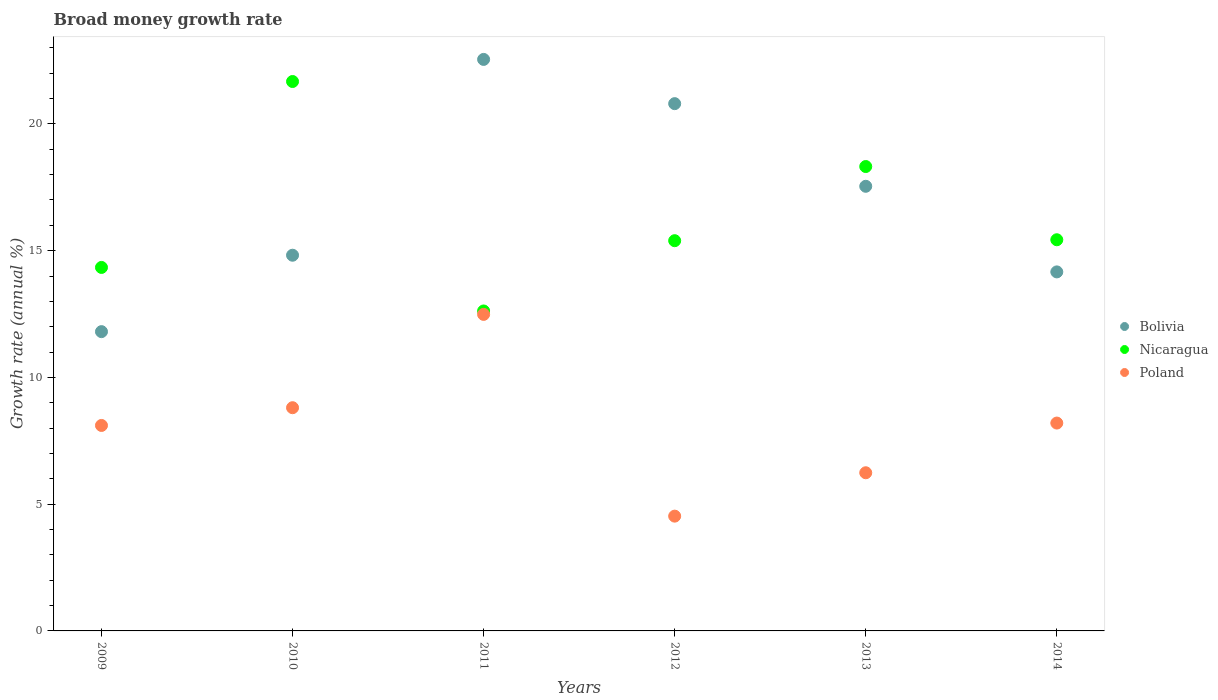How many different coloured dotlines are there?
Keep it short and to the point. 3. Is the number of dotlines equal to the number of legend labels?
Make the answer very short. Yes. What is the growth rate in Nicaragua in 2013?
Provide a succinct answer. 18.32. Across all years, what is the maximum growth rate in Nicaragua?
Your answer should be very brief. 21.67. Across all years, what is the minimum growth rate in Poland?
Your answer should be very brief. 4.53. In which year was the growth rate in Bolivia minimum?
Keep it short and to the point. 2009. What is the total growth rate in Poland in the graph?
Give a very brief answer. 48.36. What is the difference between the growth rate in Bolivia in 2009 and that in 2011?
Offer a terse response. -10.74. What is the difference between the growth rate in Nicaragua in 2011 and the growth rate in Poland in 2014?
Offer a very short reply. 4.42. What is the average growth rate in Poland per year?
Your answer should be compact. 8.06. In the year 2011, what is the difference between the growth rate in Poland and growth rate in Bolivia?
Ensure brevity in your answer.  -10.06. In how many years, is the growth rate in Poland greater than 14 %?
Ensure brevity in your answer.  0. What is the ratio of the growth rate in Nicaragua in 2010 to that in 2013?
Offer a terse response. 1.18. What is the difference between the highest and the second highest growth rate in Bolivia?
Ensure brevity in your answer.  1.75. What is the difference between the highest and the lowest growth rate in Poland?
Provide a succinct answer. 7.96. Is it the case that in every year, the sum of the growth rate in Bolivia and growth rate in Nicaragua  is greater than the growth rate in Poland?
Provide a succinct answer. Yes. Does the growth rate in Nicaragua monotonically increase over the years?
Your response must be concise. No. Is the growth rate in Nicaragua strictly greater than the growth rate in Poland over the years?
Give a very brief answer. Yes. Is the growth rate in Bolivia strictly less than the growth rate in Poland over the years?
Ensure brevity in your answer.  No. How many dotlines are there?
Your response must be concise. 3. How many years are there in the graph?
Offer a very short reply. 6. What is the difference between two consecutive major ticks on the Y-axis?
Offer a terse response. 5. Does the graph contain any zero values?
Ensure brevity in your answer.  No. What is the title of the graph?
Give a very brief answer. Broad money growth rate. What is the label or title of the Y-axis?
Keep it short and to the point. Growth rate (annual %). What is the Growth rate (annual %) in Bolivia in 2009?
Provide a short and direct response. 11.81. What is the Growth rate (annual %) in Nicaragua in 2009?
Give a very brief answer. 14.34. What is the Growth rate (annual %) in Poland in 2009?
Give a very brief answer. 8.11. What is the Growth rate (annual %) in Bolivia in 2010?
Make the answer very short. 14.82. What is the Growth rate (annual %) of Nicaragua in 2010?
Provide a succinct answer. 21.67. What is the Growth rate (annual %) of Poland in 2010?
Offer a very short reply. 8.81. What is the Growth rate (annual %) in Bolivia in 2011?
Your answer should be very brief. 22.55. What is the Growth rate (annual %) in Nicaragua in 2011?
Give a very brief answer. 12.62. What is the Growth rate (annual %) in Poland in 2011?
Your answer should be compact. 12.49. What is the Growth rate (annual %) of Bolivia in 2012?
Make the answer very short. 20.8. What is the Growth rate (annual %) in Nicaragua in 2012?
Offer a very short reply. 15.39. What is the Growth rate (annual %) in Poland in 2012?
Your answer should be very brief. 4.53. What is the Growth rate (annual %) in Bolivia in 2013?
Your answer should be compact. 17.54. What is the Growth rate (annual %) of Nicaragua in 2013?
Your answer should be compact. 18.32. What is the Growth rate (annual %) in Poland in 2013?
Your answer should be compact. 6.24. What is the Growth rate (annual %) of Bolivia in 2014?
Provide a succinct answer. 14.16. What is the Growth rate (annual %) of Nicaragua in 2014?
Offer a terse response. 15.43. What is the Growth rate (annual %) in Poland in 2014?
Offer a very short reply. 8.2. Across all years, what is the maximum Growth rate (annual %) of Bolivia?
Your answer should be very brief. 22.55. Across all years, what is the maximum Growth rate (annual %) in Nicaragua?
Your answer should be compact. 21.67. Across all years, what is the maximum Growth rate (annual %) in Poland?
Offer a terse response. 12.49. Across all years, what is the minimum Growth rate (annual %) in Bolivia?
Offer a terse response. 11.81. Across all years, what is the minimum Growth rate (annual %) of Nicaragua?
Provide a succinct answer. 12.62. Across all years, what is the minimum Growth rate (annual %) in Poland?
Keep it short and to the point. 4.53. What is the total Growth rate (annual %) in Bolivia in the graph?
Offer a very short reply. 101.67. What is the total Growth rate (annual %) of Nicaragua in the graph?
Provide a short and direct response. 97.78. What is the total Growth rate (annual %) of Poland in the graph?
Make the answer very short. 48.36. What is the difference between the Growth rate (annual %) of Bolivia in 2009 and that in 2010?
Offer a terse response. -3.01. What is the difference between the Growth rate (annual %) in Nicaragua in 2009 and that in 2010?
Offer a terse response. -7.33. What is the difference between the Growth rate (annual %) of Poland in 2009 and that in 2010?
Your answer should be compact. -0.7. What is the difference between the Growth rate (annual %) of Bolivia in 2009 and that in 2011?
Your response must be concise. -10.74. What is the difference between the Growth rate (annual %) of Nicaragua in 2009 and that in 2011?
Make the answer very short. 1.72. What is the difference between the Growth rate (annual %) of Poland in 2009 and that in 2011?
Keep it short and to the point. -4.38. What is the difference between the Growth rate (annual %) of Bolivia in 2009 and that in 2012?
Your answer should be very brief. -8.99. What is the difference between the Growth rate (annual %) in Nicaragua in 2009 and that in 2012?
Offer a terse response. -1.05. What is the difference between the Growth rate (annual %) in Poland in 2009 and that in 2012?
Keep it short and to the point. 3.58. What is the difference between the Growth rate (annual %) in Bolivia in 2009 and that in 2013?
Offer a terse response. -5.73. What is the difference between the Growth rate (annual %) of Nicaragua in 2009 and that in 2013?
Provide a short and direct response. -3.98. What is the difference between the Growth rate (annual %) in Poland in 2009 and that in 2013?
Offer a very short reply. 1.87. What is the difference between the Growth rate (annual %) of Bolivia in 2009 and that in 2014?
Your answer should be compact. -2.36. What is the difference between the Growth rate (annual %) in Nicaragua in 2009 and that in 2014?
Provide a succinct answer. -1.09. What is the difference between the Growth rate (annual %) of Poland in 2009 and that in 2014?
Make the answer very short. -0.09. What is the difference between the Growth rate (annual %) of Bolivia in 2010 and that in 2011?
Provide a short and direct response. -7.72. What is the difference between the Growth rate (annual %) in Nicaragua in 2010 and that in 2011?
Provide a succinct answer. 9.05. What is the difference between the Growth rate (annual %) in Poland in 2010 and that in 2011?
Your answer should be compact. -3.68. What is the difference between the Growth rate (annual %) of Bolivia in 2010 and that in 2012?
Offer a very short reply. -5.98. What is the difference between the Growth rate (annual %) of Nicaragua in 2010 and that in 2012?
Give a very brief answer. 6.28. What is the difference between the Growth rate (annual %) in Poland in 2010 and that in 2012?
Make the answer very short. 4.28. What is the difference between the Growth rate (annual %) in Bolivia in 2010 and that in 2013?
Your response must be concise. -2.72. What is the difference between the Growth rate (annual %) of Nicaragua in 2010 and that in 2013?
Make the answer very short. 3.35. What is the difference between the Growth rate (annual %) of Poland in 2010 and that in 2013?
Ensure brevity in your answer.  2.57. What is the difference between the Growth rate (annual %) in Bolivia in 2010 and that in 2014?
Your response must be concise. 0.66. What is the difference between the Growth rate (annual %) in Nicaragua in 2010 and that in 2014?
Your answer should be very brief. 6.24. What is the difference between the Growth rate (annual %) in Poland in 2010 and that in 2014?
Make the answer very short. 0.61. What is the difference between the Growth rate (annual %) in Bolivia in 2011 and that in 2012?
Give a very brief answer. 1.75. What is the difference between the Growth rate (annual %) of Nicaragua in 2011 and that in 2012?
Ensure brevity in your answer.  -2.77. What is the difference between the Growth rate (annual %) of Poland in 2011 and that in 2012?
Offer a terse response. 7.96. What is the difference between the Growth rate (annual %) in Bolivia in 2011 and that in 2013?
Your answer should be very brief. 5. What is the difference between the Growth rate (annual %) of Nicaragua in 2011 and that in 2013?
Offer a very short reply. -5.7. What is the difference between the Growth rate (annual %) of Poland in 2011 and that in 2013?
Your response must be concise. 6.25. What is the difference between the Growth rate (annual %) in Bolivia in 2011 and that in 2014?
Keep it short and to the point. 8.38. What is the difference between the Growth rate (annual %) in Nicaragua in 2011 and that in 2014?
Offer a terse response. -2.81. What is the difference between the Growth rate (annual %) of Poland in 2011 and that in 2014?
Your answer should be compact. 4.29. What is the difference between the Growth rate (annual %) of Bolivia in 2012 and that in 2013?
Provide a short and direct response. 3.26. What is the difference between the Growth rate (annual %) in Nicaragua in 2012 and that in 2013?
Give a very brief answer. -2.93. What is the difference between the Growth rate (annual %) of Poland in 2012 and that in 2013?
Give a very brief answer. -1.71. What is the difference between the Growth rate (annual %) in Bolivia in 2012 and that in 2014?
Provide a succinct answer. 6.64. What is the difference between the Growth rate (annual %) of Nicaragua in 2012 and that in 2014?
Provide a succinct answer. -0.04. What is the difference between the Growth rate (annual %) in Poland in 2012 and that in 2014?
Offer a very short reply. -3.67. What is the difference between the Growth rate (annual %) in Bolivia in 2013 and that in 2014?
Provide a short and direct response. 3.38. What is the difference between the Growth rate (annual %) of Nicaragua in 2013 and that in 2014?
Your answer should be very brief. 2.89. What is the difference between the Growth rate (annual %) in Poland in 2013 and that in 2014?
Your response must be concise. -1.96. What is the difference between the Growth rate (annual %) of Bolivia in 2009 and the Growth rate (annual %) of Nicaragua in 2010?
Your answer should be very brief. -9.87. What is the difference between the Growth rate (annual %) of Bolivia in 2009 and the Growth rate (annual %) of Poland in 2010?
Keep it short and to the point. 3. What is the difference between the Growth rate (annual %) in Nicaragua in 2009 and the Growth rate (annual %) in Poland in 2010?
Your answer should be very brief. 5.53. What is the difference between the Growth rate (annual %) of Bolivia in 2009 and the Growth rate (annual %) of Nicaragua in 2011?
Provide a succinct answer. -0.82. What is the difference between the Growth rate (annual %) in Bolivia in 2009 and the Growth rate (annual %) in Poland in 2011?
Ensure brevity in your answer.  -0.68. What is the difference between the Growth rate (annual %) of Nicaragua in 2009 and the Growth rate (annual %) of Poland in 2011?
Offer a terse response. 1.85. What is the difference between the Growth rate (annual %) of Bolivia in 2009 and the Growth rate (annual %) of Nicaragua in 2012?
Make the answer very short. -3.59. What is the difference between the Growth rate (annual %) of Bolivia in 2009 and the Growth rate (annual %) of Poland in 2012?
Offer a terse response. 7.28. What is the difference between the Growth rate (annual %) of Nicaragua in 2009 and the Growth rate (annual %) of Poland in 2012?
Your answer should be very brief. 9.81. What is the difference between the Growth rate (annual %) in Bolivia in 2009 and the Growth rate (annual %) in Nicaragua in 2013?
Your answer should be very brief. -6.51. What is the difference between the Growth rate (annual %) of Bolivia in 2009 and the Growth rate (annual %) of Poland in 2013?
Offer a very short reply. 5.57. What is the difference between the Growth rate (annual %) of Nicaragua in 2009 and the Growth rate (annual %) of Poland in 2013?
Make the answer very short. 8.1. What is the difference between the Growth rate (annual %) in Bolivia in 2009 and the Growth rate (annual %) in Nicaragua in 2014?
Make the answer very short. -3.62. What is the difference between the Growth rate (annual %) in Bolivia in 2009 and the Growth rate (annual %) in Poland in 2014?
Your response must be concise. 3.61. What is the difference between the Growth rate (annual %) of Nicaragua in 2009 and the Growth rate (annual %) of Poland in 2014?
Your answer should be very brief. 6.14. What is the difference between the Growth rate (annual %) in Bolivia in 2010 and the Growth rate (annual %) in Nicaragua in 2011?
Your answer should be very brief. 2.2. What is the difference between the Growth rate (annual %) in Bolivia in 2010 and the Growth rate (annual %) in Poland in 2011?
Provide a short and direct response. 2.33. What is the difference between the Growth rate (annual %) in Nicaragua in 2010 and the Growth rate (annual %) in Poland in 2011?
Provide a short and direct response. 9.19. What is the difference between the Growth rate (annual %) in Bolivia in 2010 and the Growth rate (annual %) in Nicaragua in 2012?
Provide a succinct answer. -0.57. What is the difference between the Growth rate (annual %) of Bolivia in 2010 and the Growth rate (annual %) of Poland in 2012?
Your answer should be very brief. 10.29. What is the difference between the Growth rate (annual %) of Nicaragua in 2010 and the Growth rate (annual %) of Poland in 2012?
Give a very brief answer. 17.15. What is the difference between the Growth rate (annual %) of Bolivia in 2010 and the Growth rate (annual %) of Nicaragua in 2013?
Offer a terse response. -3.5. What is the difference between the Growth rate (annual %) of Bolivia in 2010 and the Growth rate (annual %) of Poland in 2013?
Your response must be concise. 8.58. What is the difference between the Growth rate (annual %) in Nicaragua in 2010 and the Growth rate (annual %) in Poland in 2013?
Provide a succinct answer. 15.43. What is the difference between the Growth rate (annual %) in Bolivia in 2010 and the Growth rate (annual %) in Nicaragua in 2014?
Ensure brevity in your answer.  -0.61. What is the difference between the Growth rate (annual %) in Bolivia in 2010 and the Growth rate (annual %) in Poland in 2014?
Give a very brief answer. 6.62. What is the difference between the Growth rate (annual %) of Nicaragua in 2010 and the Growth rate (annual %) of Poland in 2014?
Make the answer very short. 13.47. What is the difference between the Growth rate (annual %) of Bolivia in 2011 and the Growth rate (annual %) of Nicaragua in 2012?
Provide a succinct answer. 7.15. What is the difference between the Growth rate (annual %) of Bolivia in 2011 and the Growth rate (annual %) of Poland in 2012?
Your answer should be very brief. 18.02. What is the difference between the Growth rate (annual %) of Nicaragua in 2011 and the Growth rate (annual %) of Poland in 2012?
Make the answer very short. 8.09. What is the difference between the Growth rate (annual %) in Bolivia in 2011 and the Growth rate (annual %) in Nicaragua in 2013?
Make the answer very short. 4.23. What is the difference between the Growth rate (annual %) of Bolivia in 2011 and the Growth rate (annual %) of Poland in 2013?
Offer a terse response. 16.31. What is the difference between the Growth rate (annual %) in Nicaragua in 2011 and the Growth rate (annual %) in Poland in 2013?
Provide a short and direct response. 6.38. What is the difference between the Growth rate (annual %) in Bolivia in 2011 and the Growth rate (annual %) in Nicaragua in 2014?
Provide a short and direct response. 7.11. What is the difference between the Growth rate (annual %) in Bolivia in 2011 and the Growth rate (annual %) in Poland in 2014?
Keep it short and to the point. 14.35. What is the difference between the Growth rate (annual %) in Nicaragua in 2011 and the Growth rate (annual %) in Poland in 2014?
Your response must be concise. 4.42. What is the difference between the Growth rate (annual %) of Bolivia in 2012 and the Growth rate (annual %) of Nicaragua in 2013?
Make the answer very short. 2.48. What is the difference between the Growth rate (annual %) of Bolivia in 2012 and the Growth rate (annual %) of Poland in 2013?
Provide a short and direct response. 14.56. What is the difference between the Growth rate (annual %) in Nicaragua in 2012 and the Growth rate (annual %) in Poland in 2013?
Your answer should be compact. 9.15. What is the difference between the Growth rate (annual %) of Bolivia in 2012 and the Growth rate (annual %) of Nicaragua in 2014?
Give a very brief answer. 5.37. What is the difference between the Growth rate (annual %) of Bolivia in 2012 and the Growth rate (annual %) of Poland in 2014?
Give a very brief answer. 12.6. What is the difference between the Growth rate (annual %) in Nicaragua in 2012 and the Growth rate (annual %) in Poland in 2014?
Provide a short and direct response. 7.19. What is the difference between the Growth rate (annual %) of Bolivia in 2013 and the Growth rate (annual %) of Nicaragua in 2014?
Offer a terse response. 2.11. What is the difference between the Growth rate (annual %) in Bolivia in 2013 and the Growth rate (annual %) in Poland in 2014?
Provide a short and direct response. 9.34. What is the difference between the Growth rate (annual %) of Nicaragua in 2013 and the Growth rate (annual %) of Poland in 2014?
Your answer should be very brief. 10.12. What is the average Growth rate (annual %) of Bolivia per year?
Your response must be concise. 16.95. What is the average Growth rate (annual %) in Nicaragua per year?
Provide a short and direct response. 16.3. What is the average Growth rate (annual %) in Poland per year?
Offer a terse response. 8.06. In the year 2009, what is the difference between the Growth rate (annual %) of Bolivia and Growth rate (annual %) of Nicaragua?
Offer a terse response. -2.53. In the year 2009, what is the difference between the Growth rate (annual %) in Bolivia and Growth rate (annual %) in Poland?
Your answer should be very brief. 3.7. In the year 2009, what is the difference between the Growth rate (annual %) in Nicaragua and Growth rate (annual %) in Poland?
Provide a short and direct response. 6.23. In the year 2010, what is the difference between the Growth rate (annual %) in Bolivia and Growth rate (annual %) in Nicaragua?
Give a very brief answer. -6.85. In the year 2010, what is the difference between the Growth rate (annual %) of Bolivia and Growth rate (annual %) of Poland?
Your response must be concise. 6.02. In the year 2010, what is the difference between the Growth rate (annual %) of Nicaragua and Growth rate (annual %) of Poland?
Your answer should be very brief. 12.87. In the year 2011, what is the difference between the Growth rate (annual %) of Bolivia and Growth rate (annual %) of Nicaragua?
Ensure brevity in your answer.  9.92. In the year 2011, what is the difference between the Growth rate (annual %) of Bolivia and Growth rate (annual %) of Poland?
Your response must be concise. 10.06. In the year 2011, what is the difference between the Growth rate (annual %) of Nicaragua and Growth rate (annual %) of Poland?
Keep it short and to the point. 0.14. In the year 2012, what is the difference between the Growth rate (annual %) in Bolivia and Growth rate (annual %) in Nicaragua?
Your answer should be compact. 5.41. In the year 2012, what is the difference between the Growth rate (annual %) in Bolivia and Growth rate (annual %) in Poland?
Offer a very short reply. 16.27. In the year 2012, what is the difference between the Growth rate (annual %) of Nicaragua and Growth rate (annual %) of Poland?
Ensure brevity in your answer.  10.87. In the year 2013, what is the difference between the Growth rate (annual %) of Bolivia and Growth rate (annual %) of Nicaragua?
Offer a very short reply. -0.78. In the year 2013, what is the difference between the Growth rate (annual %) in Bolivia and Growth rate (annual %) in Poland?
Provide a short and direct response. 11.3. In the year 2013, what is the difference between the Growth rate (annual %) in Nicaragua and Growth rate (annual %) in Poland?
Give a very brief answer. 12.08. In the year 2014, what is the difference between the Growth rate (annual %) of Bolivia and Growth rate (annual %) of Nicaragua?
Your response must be concise. -1.27. In the year 2014, what is the difference between the Growth rate (annual %) of Bolivia and Growth rate (annual %) of Poland?
Make the answer very short. 5.96. In the year 2014, what is the difference between the Growth rate (annual %) of Nicaragua and Growth rate (annual %) of Poland?
Provide a succinct answer. 7.23. What is the ratio of the Growth rate (annual %) in Bolivia in 2009 to that in 2010?
Provide a short and direct response. 0.8. What is the ratio of the Growth rate (annual %) in Nicaragua in 2009 to that in 2010?
Provide a short and direct response. 0.66. What is the ratio of the Growth rate (annual %) of Poland in 2009 to that in 2010?
Keep it short and to the point. 0.92. What is the ratio of the Growth rate (annual %) in Bolivia in 2009 to that in 2011?
Offer a very short reply. 0.52. What is the ratio of the Growth rate (annual %) in Nicaragua in 2009 to that in 2011?
Your answer should be compact. 1.14. What is the ratio of the Growth rate (annual %) in Poland in 2009 to that in 2011?
Provide a short and direct response. 0.65. What is the ratio of the Growth rate (annual %) in Bolivia in 2009 to that in 2012?
Provide a short and direct response. 0.57. What is the ratio of the Growth rate (annual %) in Nicaragua in 2009 to that in 2012?
Ensure brevity in your answer.  0.93. What is the ratio of the Growth rate (annual %) in Poland in 2009 to that in 2012?
Your answer should be very brief. 1.79. What is the ratio of the Growth rate (annual %) of Bolivia in 2009 to that in 2013?
Your answer should be compact. 0.67. What is the ratio of the Growth rate (annual %) of Nicaragua in 2009 to that in 2013?
Keep it short and to the point. 0.78. What is the ratio of the Growth rate (annual %) of Poland in 2009 to that in 2013?
Keep it short and to the point. 1.3. What is the ratio of the Growth rate (annual %) in Bolivia in 2009 to that in 2014?
Your answer should be compact. 0.83. What is the ratio of the Growth rate (annual %) in Nicaragua in 2009 to that in 2014?
Offer a terse response. 0.93. What is the ratio of the Growth rate (annual %) in Bolivia in 2010 to that in 2011?
Your answer should be compact. 0.66. What is the ratio of the Growth rate (annual %) of Nicaragua in 2010 to that in 2011?
Make the answer very short. 1.72. What is the ratio of the Growth rate (annual %) in Poland in 2010 to that in 2011?
Provide a short and direct response. 0.71. What is the ratio of the Growth rate (annual %) in Bolivia in 2010 to that in 2012?
Ensure brevity in your answer.  0.71. What is the ratio of the Growth rate (annual %) in Nicaragua in 2010 to that in 2012?
Make the answer very short. 1.41. What is the ratio of the Growth rate (annual %) of Poland in 2010 to that in 2012?
Make the answer very short. 1.94. What is the ratio of the Growth rate (annual %) in Bolivia in 2010 to that in 2013?
Provide a short and direct response. 0.84. What is the ratio of the Growth rate (annual %) of Nicaragua in 2010 to that in 2013?
Your response must be concise. 1.18. What is the ratio of the Growth rate (annual %) in Poland in 2010 to that in 2013?
Ensure brevity in your answer.  1.41. What is the ratio of the Growth rate (annual %) in Bolivia in 2010 to that in 2014?
Provide a short and direct response. 1.05. What is the ratio of the Growth rate (annual %) in Nicaragua in 2010 to that in 2014?
Keep it short and to the point. 1.4. What is the ratio of the Growth rate (annual %) in Poland in 2010 to that in 2014?
Ensure brevity in your answer.  1.07. What is the ratio of the Growth rate (annual %) in Bolivia in 2011 to that in 2012?
Give a very brief answer. 1.08. What is the ratio of the Growth rate (annual %) of Nicaragua in 2011 to that in 2012?
Your answer should be compact. 0.82. What is the ratio of the Growth rate (annual %) in Poland in 2011 to that in 2012?
Provide a short and direct response. 2.76. What is the ratio of the Growth rate (annual %) of Bolivia in 2011 to that in 2013?
Your answer should be very brief. 1.29. What is the ratio of the Growth rate (annual %) of Nicaragua in 2011 to that in 2013?
Give a very brief answer. 0.69. What is the ratio of the Growth rate (annual %) in Poland in 2011 to that in 2013?
Your answer should be very brief. 2. What is the ratio of the Growth rate (annual %) of Bolivia in 2011 to that in 2014?
Your answer should be very brief. 1.59. What is the ratio of the Growth rate (annual %) of Nicaragua in 2011 to that in 2014?
Ensure brevity in your answer.  0.82. What is the ratio of the Growth rate (annual %) in Poland in 2011 to that in 2014?
Your answer should be compact. 1.52. What is the ratio of the Growth rate (annual %) of Bolivia in 2012 to that in 2013?
Provide a short and direct response. 1.19. What is the ratio of the Growth rate (annual %) of Nicaragua in 2012 to that in 2013?
Your response must be concise. 0.84. What is the ratio of the Growth rate (annual %) in Poland in 2012 to that in 2013?
Keep it short and to the point. 0.73. What is the ratio of the Growth rate (annual %) of Bolivia in 2012 to that in 2014?
Offer a very short reply. 1.47. What is the ratio of the Growth rate (annual %) in Nicaragua in 2012 to that in 2014?
Ensure brevity in your answer.  1. What is the ratio of the Growth rate (annual %) of Poland in 2012 to that in 2014?
Offer a very short reply. 0.55. What is the ratio of the Growth rate (annual %) in Bolivia in 2013 to that in 2014?
Your answer should be very brief. 1.24. What is the ratio of the Growth rate (annual %) in Nicaragua in 2013 to that in 2014?
Make the answer very short. 1.19. What is the ratio of the Growth rate (annual %) in Poland in 2013 to that in 2014?
Provide a succinct answer. 0.76. What is the difference between the highest and the second highest Growth rate (annual %) of Bolivia?
Your answer should be compact. 1.75. What is the difference between the highest and the second highest Growth rate (annual %) in Nicaragua?
Your answer should be very brief. 3.35. What is the difference between the highest and the second highest Growth rate (annual %) in Poland?
Provide a short and direct response. 3.68. What is the difference between the highest and the lowest Growth rate (annual %) of Bolivia?
Keep it short and to the point. 10.74. What is the difference between the highest and the lowest Growth rate (annual %) in Nicaragua?
Provide a short and direct response. 9.05. What is the difference between the highest and the lowest Growth rate (annual %) in Poland?
Your answer should be compact. 7.96. 